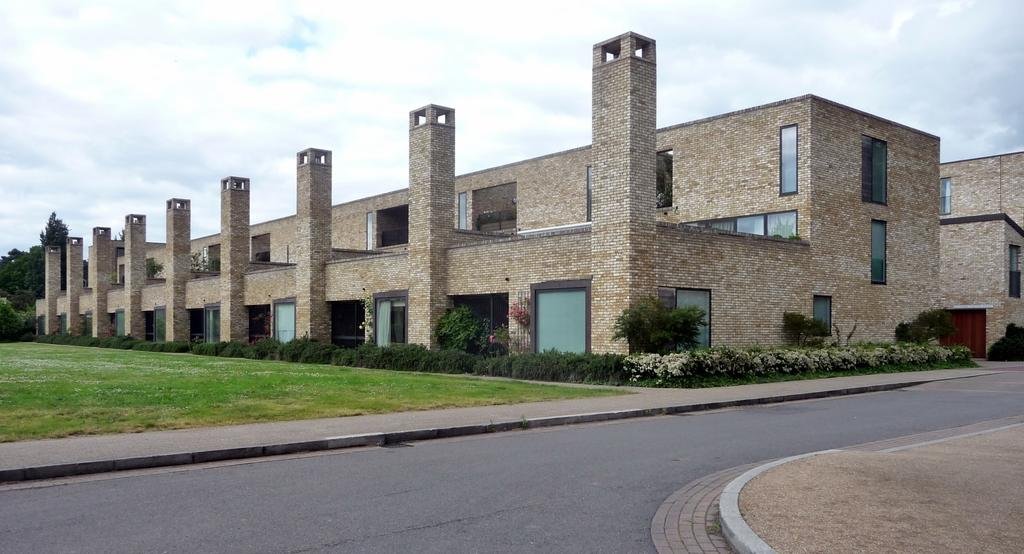What type of vegetation can be seen in the image? There is grass, plants, and trees in the image. What type of structures are present in the image? There are buildings, pillars, and doors in the image. What part of the natural environment is visible in the image? The sky is visible in the image. Can you describe the setting where the image might have been taken? The image may have been taken on a road, as suggested by the presence of buildings and the open sky. Can you tell me how many daughters are visible in the image? There are no daughters present in the image. Is there an airplane flying in the sky in the image? The sky is visible in the image, but there is no airplane present. Can you see a rat running on the grass in the image? There is no rat present in the image. 